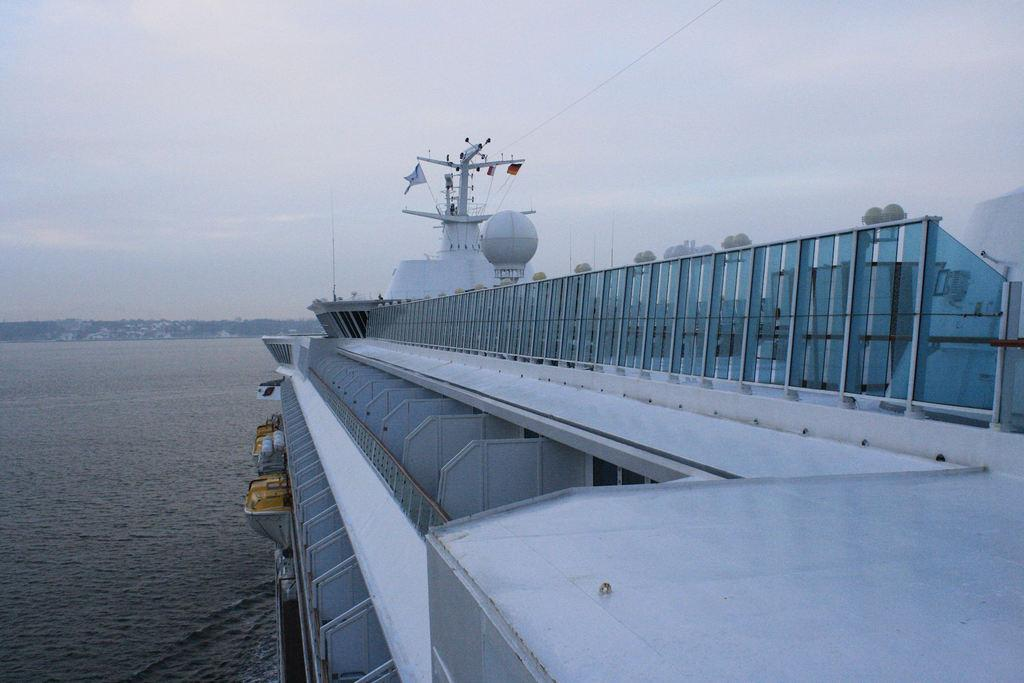What is the main subject of the image? The main subject of the image is a ship. Where is the ship located in the image? The ship is on the water. What can be seen on the ship? There is a flag on the ship, as well as lights and grills. What else is visible in the image besides the ship? Mountains and the sky are visible in the image. What type of soap is being used to clean the ship in the image? There is no soap present in the image, and no cleaning activity is depicted. 